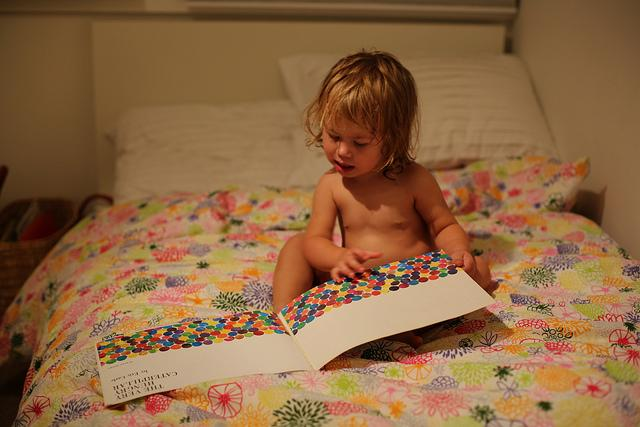On what does the child focus here? book 